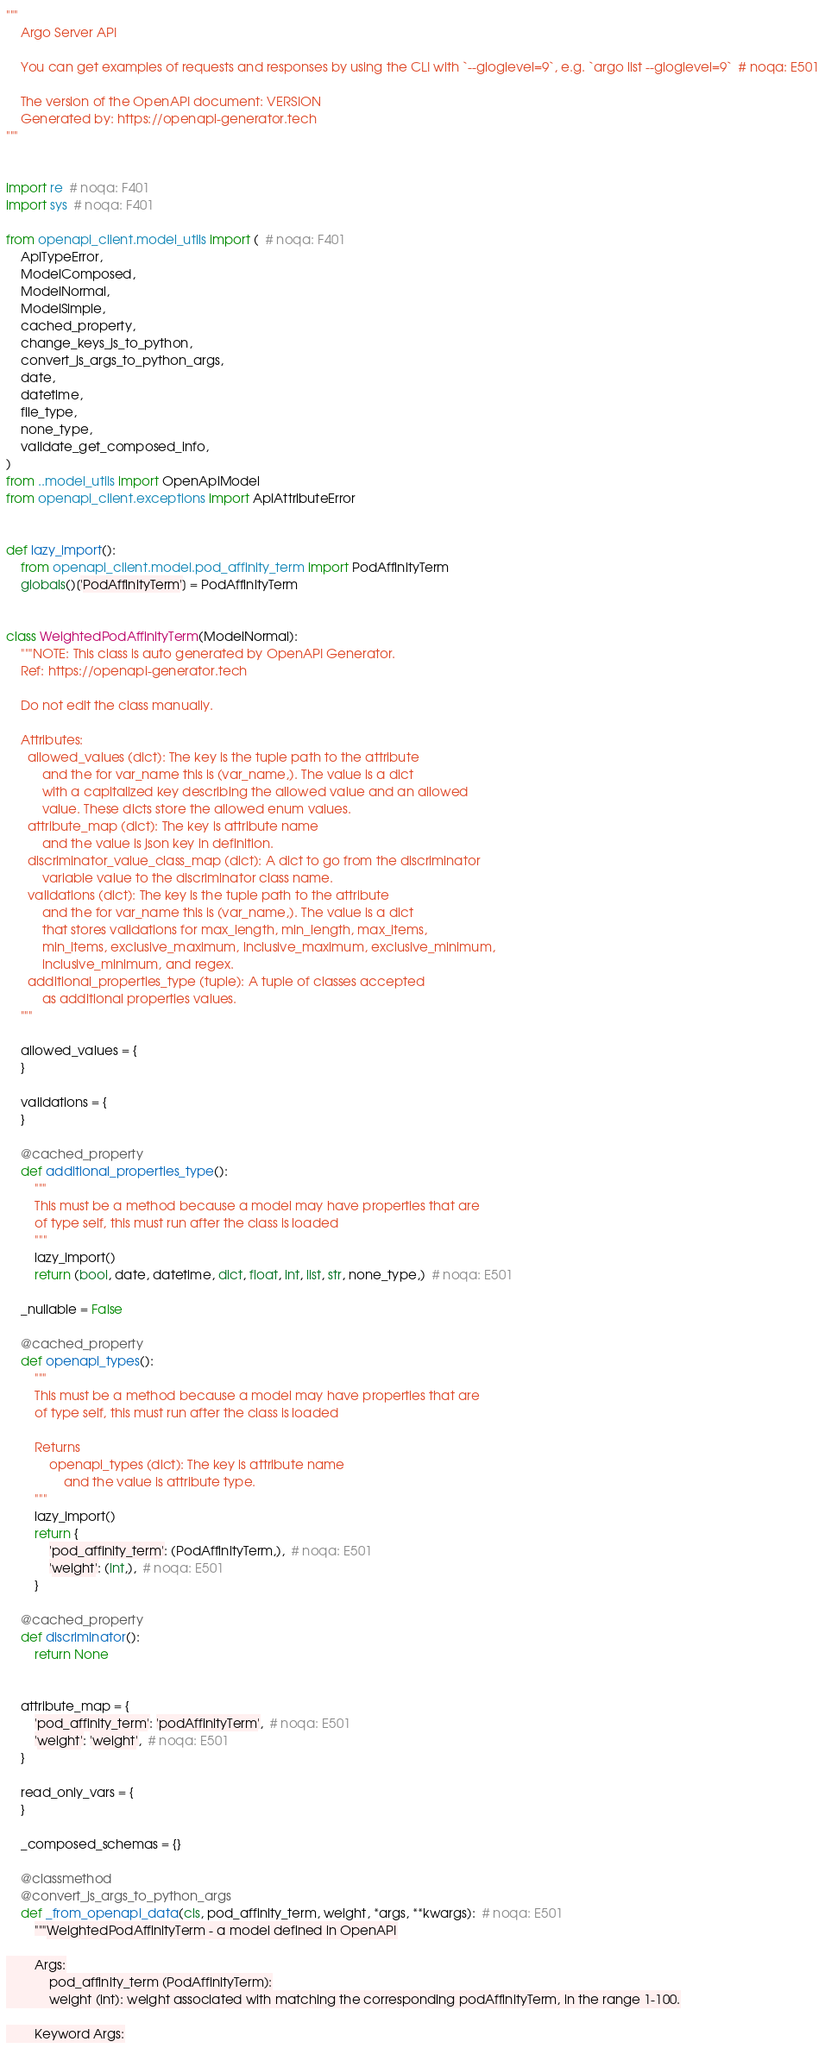Convert code to text. <code><loc_0><loc_0><loc_500><loc_500><_Python_>"""
    Argo Server API

    You can get examples of requests and responses by using the CLI with `--gloglevel=9`, e.g. `argo list --gloglevel=9`  # noqa: E501

    The version of the OpenAPI document: VERSION
    Generated by: https://openapi-generator.tech
"""


import re  # noqa: F401
import sys  # noqa: F401

from openapi_client.model_utils import (  # noqa: F401
    ApiTypeError,
    ModelComposed,
    ModelNormal,
    ModelSimple,
    cached_property,
    change_keys_js_to_python,
    convert_js_args_to_python_args,
    date,
    datetime,
    file_type,
    none_type,
    validate_get_composed_info,
)
from ..model_utils import OpenApiModel
from openapi_client.exceptions import ApiAttributeError


def lazy_import():
    from openapi_client.model.pod_affinity_term import PodAffinityTerm
    globals()['PodAffinityTerm'] = PodAffinityTerm


class WeightedPodAffinityTerm(ModelNormal):
    """NOTE: This class is auto generated by OpenAPI Generator.
    Ref: https://openapi-generator.tech

    Do not edit the class manually.

    Attributes:
      allowed_values (dict): The key is the tuple path to the attribute
          and the for var_name this is (var_name,). The value is a dict
          with a capitalized key describing the allowed value and an allowed
          value. These dicts store the allowed enum values.
      attribute_map (dict): The key is attribute name
          and the value is json key in definition.
      discriminator_value_class_map (dict): A dict to go from the discriminator
          variable value to the discriminator class name.
      validations (dict): The key is the tuple path to the attribute
          and the for var_name this is (var_name,). The value is a dict
          that stores validations for max_length, min_length, max_items,
          min_items, exclusive_maximum, inclusive_maximum, exclusive_minimum,
          inclusive_minimum, and regex.
      additional_properties_type (tuple): A tuple of classes accepted
          as additional properties values.
    """

    allowed_values = {
    }

    validations = {
    }

    @cached_property
    def additional_properties_type():
        """
        This must be a method because a model may have properties that are
        of type self, this must run after the class is loaded
        """
        lazy_import()
        return (bool, date, datetime, dict, float, int, list, str, none_type,)  # noqa: E501

    _nullable = False

    @cached_property
    def openapi_types():
        """
        This must be a method because a model may have properties that are
        of type self, this must run after the class is loaded

        Returns
            openapi_types (dict): The key is attribute name
                and the value is attribute type.
        """
        lazy_import()
        return {
            'pod_affinity_term': (PodAffinityTerm,),  # noqa: E501
            'weight': (int,),  # noqa: E501
        }

    @cached_property
    def discriminator():
        return None


    attribute_map = {
        'pod_affinity_term': 'podAffinityTerm',  # noqa: E501
        'weight': 'weight',  # noqa: E501
    }

    read_only_vars = {
    }

    _composed_schemas = {}

    @classmethod
    @convert_js_args_to_python_args
    def _from_openapi_data(cls, pod_affinity_term, weight, *args, **kwargs):  # noqa: E501
        """WeightedPodAffinityTerm - a model defined in OpenAPI

        Args:
            pod_affinity_term (PodAffinityTerm):
            weight (int): weight associated with matching the corresponding podAffinityTerm, in the range 1-100.

        Keyword Args:</code> 